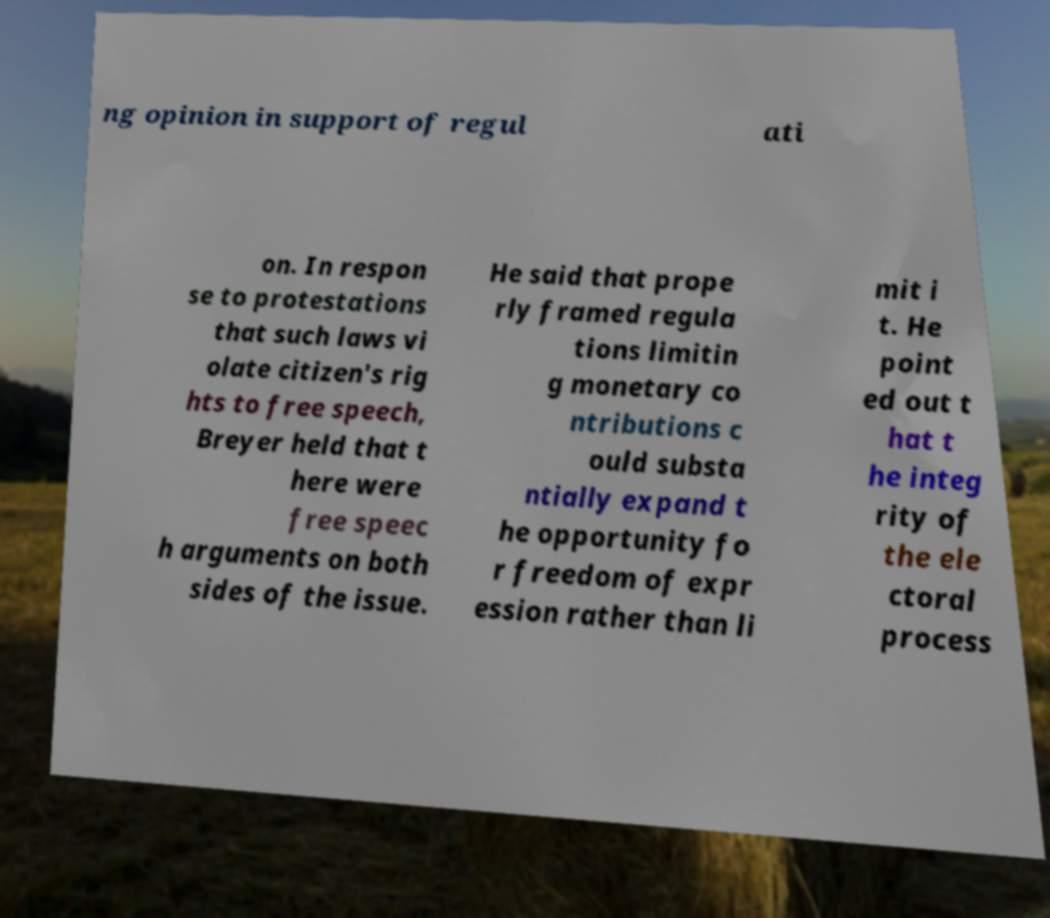Can you accurately transcribe the text from the provided image for me? ng opinion in support of regul ati on. In respon se to protestations that such laws vi olate citizen's rig hts to free speech, Breyer held that t here were free speec h arguments on both sides of the issue. He said that prope rly framed regula tions limitin g monetary co ntributions c ould substa ntially expand t he opportunity fo r freedom of expr ession rather than li mit i t. He point ed out t hat t he integ rity of the ele ctoral process 